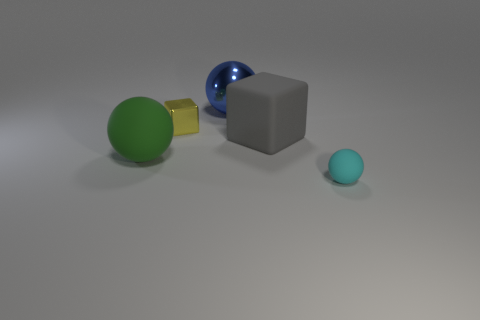Are there any blue balls on the right side of the rubber thing right of the cube on the right side of the large blue metallic thing?
Your answer should be very brief. No. Is the metallic ball the same color as the tiny ball?
Ensure brevity in your answer.  No. Is the number of tiny yellow things less than the number of small purple matte objects?
Give a very brief answer. No. Is the big ball left of the tiny yellow metallic cube made of the same material as the tiny thing that is to the left of the cyan matte sphere?
Offer a terse response. No. Are there fewer blue balls on the left side of the gray matte object than yellow matte cylinders?
Provide a succinct answer. No. How many big rubber things are on the left side of the cube that is on the right side of the big blue thing?
Offer a terse response. 1. There is a sphere that is right of the small yellow object and in front of the big blue ball; what size is it?
Ensure brevity in your answer.  Small. Is there any other thing that is made of the same material as the gray block?
Offer a terse response. Yes. Is the cyan ball made of the same material as the big gray block that is to the right of the large green matte object?
Your answer should be very brief. Yes. Is the number of tiny shiny cubes that are to the left of the big green thing less than the number of small cyan balls in front of the large shiny sphere?
Provide a succinct answer. Yes. 